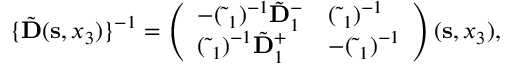Convert formula to latex. <formula><loc_0><loc_0><loc_500><loc_500>\begin{array} { r } { \{ \tilde { D } ( { s } , x _ { 3 } ) \} ^ { - 1 } = \left ( \begin{array} { l l } { - ( \tilde { \Delta } _ { 1 } ) ^ { - 1 } \tilde { D } _ { 1 } ^ { - } } & { ( \tilde { \Delta } _ { 1 } ) ^ { - 1 } } \\ { ( \tilde { \Delta } _ { 1 } ) ^ { - 1 } \tilde { D } _ { 1 } ^ { + } } & { - ( \tilde { \Delta } _ { 1 } ) ^ { - 1 } } \end{array} \right ) ( { s } , x _ { 3 } ) , } \end{array}</formula> 